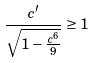<formula> <loc_0><loc_0><loc_500><loc_500>\frac { c ^ { \prime } } { \sqrt { 1 - \frac { c ^ { 6 } } { 9 } } } \geq 1</formula> 